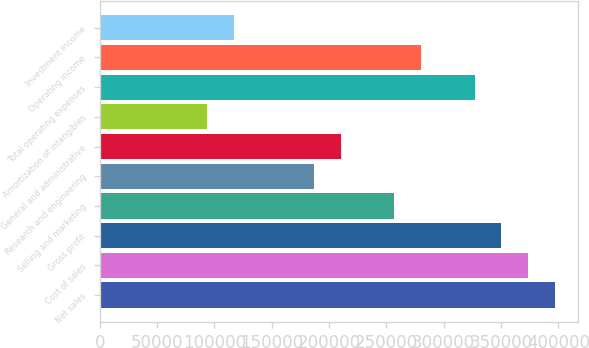Convert chart to OTSL. <chart><loc_0><loc_0><loc_500><loc_500><bar_chart><fcel>Net sales<fcel>Cost of sales<fcel>Gross profit<fcel>Selling and marketing<fcel>Research and engineering<fcel>General and administrative<fcel>Amortization of intangibles<fcel>Total operating expenses<fcel>Operating income<fcel>Investment income<nl><fcel>397074<fcel>373716<fcel>350359<fcel>256930<fcel>186858<fcel>210216<fcel>93429.5<fcel>327002<fcel>280287<fcel>116787<nl></chart> 